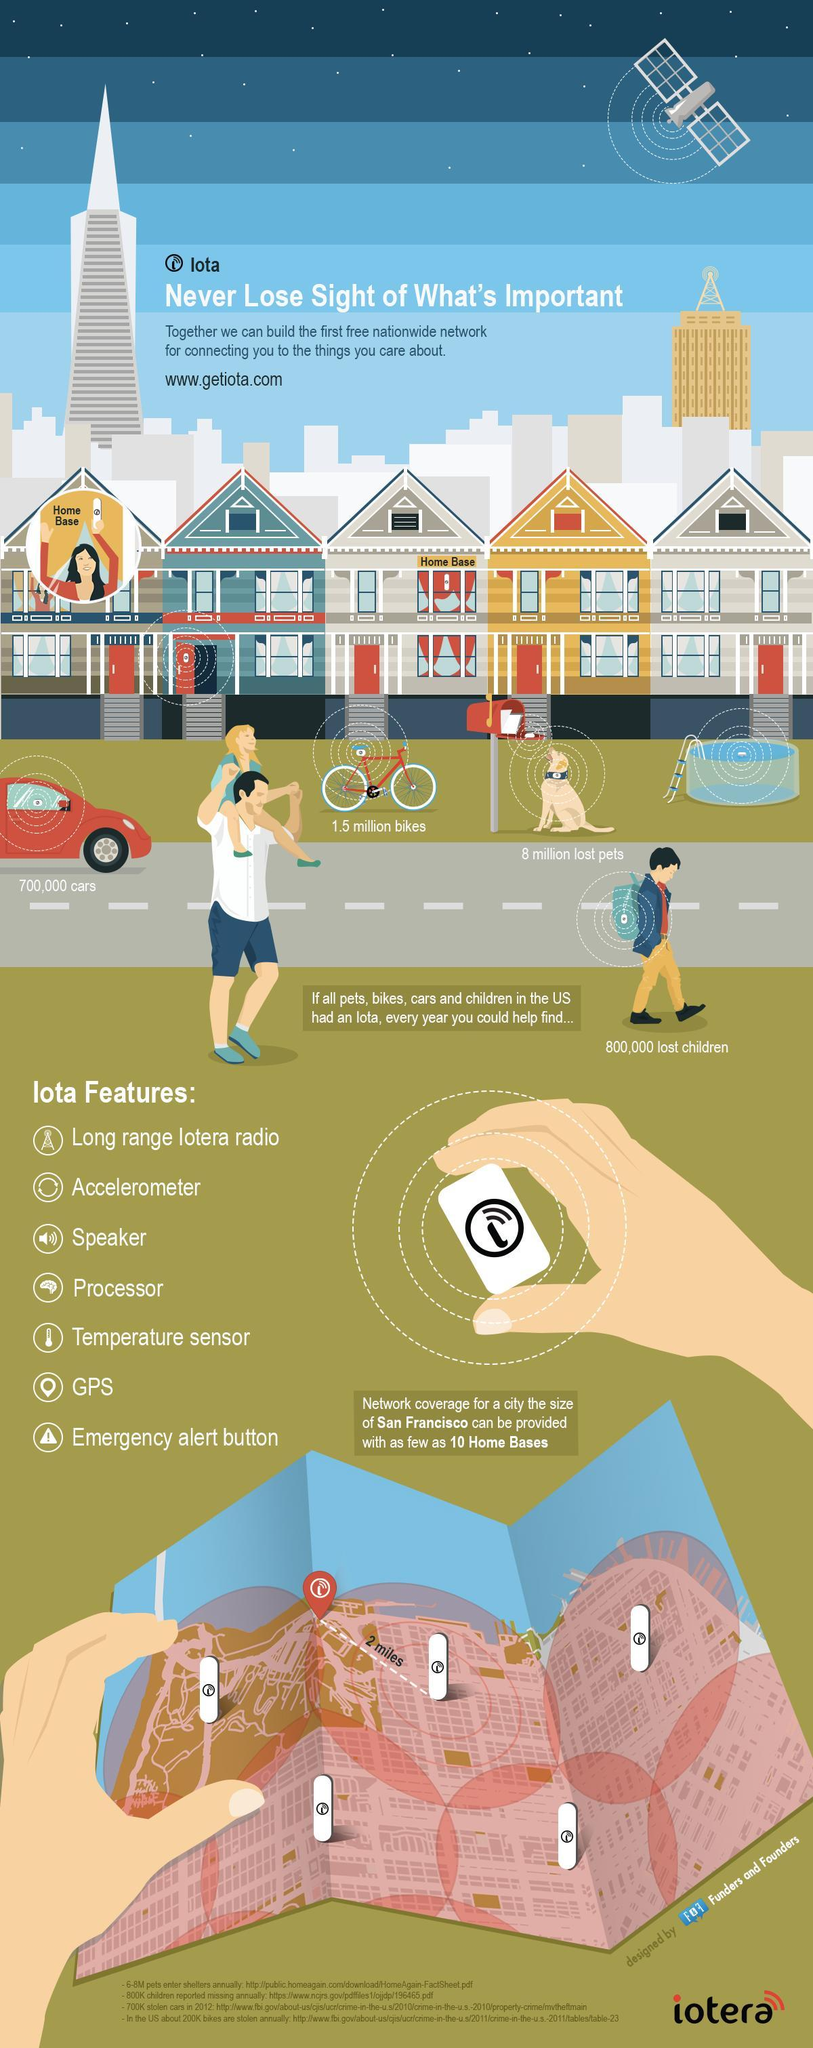How many features of Iota are mentioned here?
Answer the question with a short phrase. 7 How many images of Iota home bases are shown on the map? 5 What is shown in the child's bag? Iota What is the maximum network coverage (in miles) provided by an iota homebase? 2 miles How much was the number of lost pets more than lost bikes (in million)? 6.5 What are the last two Iota features mentioned here? GPS, emergency alert button 